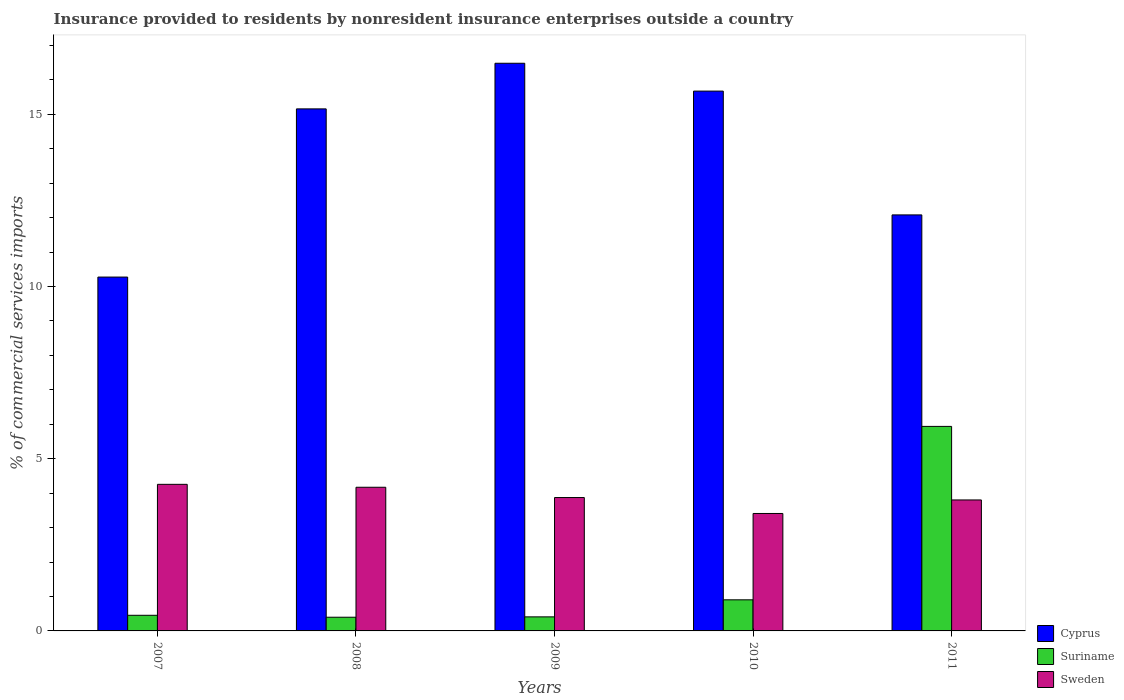How many groups of bars are there?
Provide a short and direct response. 5. Are the number of bars on each tick of the X-axis equal?
Give a very brief answer. Yes. In how many cases, is the number of bars for a given year not equal to the number of legend labels?
Make the answer very short. 0. What is the Insurance provided to residents in Suriname in 2010?
Your response must be concise. 0.9. Across all years, what is the maximum Insurance provided to residents in Sweden?
Provide a succinct answer. 4.26. Across all years, what is the minimum Insurance provided to residents in Sweden?
Your response must be concise. 3.41. In which year was the Insurance provided to residents in Cyprus maximum?
Your response must be concise. 2009. In which year was the Insurance provided to residents in Suriname minimum?
Ensure brevity in your answer.  2008. What is the total Insurance provided to residents in Sweden in the graph?
Your response must be concise. 19.52. What is the difference between the Insurance provided to residents in Sweden in 2010 and that in 2011?
Ensure brevity in your answer.  -0.39. What is the difference between the Insurance provided to residents in Sweden in 2007 and the Insurance provided to residents in Suriname in 2009?
Keep it short and to the point. 3.85. What is the average Insurance provided to residents in Cyprus per year?
Your answer should be very brief. 13.93. In the year 2011, what is the difference between the Insurance provided to residents in Cyprus and Insurance provided to residents in Sweden?
Provide a short and direct response. 8.28. In how many years, is the Insurance provided to residents in Cyprus greater than 16 %?
Provide a short and direct response. 1. What is the ratio of the Insurance provided to residents in Sweden in 2007 to that in 2008?
Provide a short and direct response. 1.02. Is the Insurance provided to residents in Cyprus in 2009 less than that in 2010?
Keep it short and to the point. No. What is the difference between the highest and the second highest Insurance provided to residents in Cyprus?
Offer a very short reply. 0.81. What is the difference between the highest and the lowest Insurance provided to residents in Cyprus?
Offer a terse response. 6.21. In how many years, is the Insurance provided to residents in Cyprus greater than the average Insurance provided to residents in Cyprus taken over all years?
Your answer should be very brief. 3. Is the sum of the Insurance provided to residents in Sweden in 2010 and 2011 greater than the maximum Insurance provided to residents in Cyprus across all years?
Provide a succinct answer. No. What does the 1st bar from the left in 2008 represents?
Your answer should be compact. Cyprus. What does the 3rd bar from the right in 2010 represents?
Ensure brevity in your answer.  Cyprus. Are all the bars in the graph horizontal?
Ensure brevity in your answer.  No. How many years are there in the graph?
Your response must be concise. 5. What is the difference between two consecutive major ticks on the Y-axis?
Offer a terse response. 5. Are the values on the major ticks of Y-axis written in scientific E-notation?
Keep it short and to the point. No. Does the graph contain any zero values?
Provide a succinct answer. No. Where does the legend appear in the graph?
Provide a succinct answer. Bottom right. How are the legend labels stacked?
Make the answer very short. Vertical. What is the title of the graph?
Ensure brevity in your answer.  Insurance provided to residents by nonresident insurance enterprises outside a country. Does "Croatia" appear as one of the legend labels in the graph?
Give a very brief answer. No. What is the label or title of the X-axis?
Your answer should be compact. Years. What is the label or title of the Y-axis?
Provide a succinct answer. % of commercial services imports. What is the % of commercial services imports of Cyprus in 2007?
Your answer should be compact. 10.28. What is the % of commercial services imports of Suriname in 2007?
Give a very brief answer. 0.45. What is the % of commercial services imports of Sweden in 2007?
Give a very brief answer. 4.26. What is the % of commercial services imports in Cyprus in 2008?
Make the answer very short. 15.16. What is the % of commercial services imports in Suriname in 2008?
Keep it short and to the point. 0.4. What is the % of commercial services imports in Sweden in 2008?
Your response must be concise. 4.17. What is the % of commercial services imports of Cyprus in 2009?
Ensure brevity in your answer.  16.48. What is the % of commercial services imports of Suriname in 2009?
Offer a terse response. 0.41. What is the % of commercial services imports of Sweden in 2009?
Keep it short and to the point. 3.87. What is the % of commercial services imports in Cyprus in 2010?
Ensure brevity in your answer.  15.68. What is the % of commercial services imports of Suriname in 2010?
Provide a succinct answer. 0.9. What is the % of commercial services imports of Sweden in 2010?
Ensure brevity in your answer.  3.41. What is the % of commercial services imports of Cyprus in 2011?
Your answer should be compact. 12.08. What is the % of commercial services imports in Suriname in 2011?
Your answer should be compact. 5.94. What is the % of commercial services imports of Sweden in 2011?
Your response must be concise. 3.8. Across all years, what is the maximum % of commercial services imports of Cyprus?
Make the answer very short. 16.48. Across all years, what is the maximum % of commercial services imports of Suriname?
Provide a succinct answer. 5.94. Across all years, what is the maximum % of commercial services imports of Sweden?
Provide a succinct answer. 4.26. Across all years, what is the minimum % of commercial services imports of Cyprus?
Offer a very short reply. 10.28. Across all years, what is the minimum % of commercial services imports of Suriname?
Your response must be concise. 0.4. Across all years, what is the minimum % of commercial services imports of Sweden?
Your answer should be very brief. 3.41. What is the total % of commercial services imports of Cyprus in the graph?
Your answer should be compact. 69.67. What is the total % of commercial services imports of Suriname in the graph?
Offer a very short reply. 8.1. What is the total % of commercial services imports in Sweden in the graph?
Offer a very short reply. 19.52. What is the difference between the % of commercial services imports of Cyprus in 2007 and that in 2008?
Make the answer very short. -4.88. What is the difference between the % of commercial services imports of Suriname in 2007 and that in 2008?
Give a very brief answer. 0.06. What is the difference between the % of commercial services imports in Sweden in 2007 and that in 2008?
Make the answer very short. 0.08. What is the difference between the % of commercial services imports of Cyprus in 2007 and that in 2009?
Give a very brief answer. -6.21. What is the difference between the % of commercial services imports in Suriname in 2007 and that in 2009?
Ensure brevity in your answer.  0.05. What is the difference between the % of commercial services imports of Sweden in 2007 and that in 2009?
Offer a terse response. 0.38. What is the difference between the % of commercial services imports in Cyprus in 2007 and that in 2010?
Provide a short and direct response. -5.4. What is the difference between the % of commercial services imports in Suriname in 2007 and that in 2010?
Provide a succinct answer. -0.45. What is the difference between the % of commercial services imports in Sweden in 2007 and that in 2010?
Your answer should be compact. 0.85. What is the difference between the % of commercial services imports of Cyprus in 2007 and that in 2011?
Provide a short and direct response. -1.81. What is the difference between the % of commercial services imports in Suriname in 2007 and that in 2011?
Offer a terse response. -5.49. What is the difference between the % of commercial services imports of Sweden in 2007 and that in 2011?
Provide a succinct answer. 0.45. What is the difference between the % of commercial services imports in Cyprus in 2008 and that in 2009?
Offer a terse response. -1.32. What is the difference between the % of commercial services imports in Suriname in 2008 and that in 2009?
Your answer should be compact. -0.01. What is the difference between the % of commercial services imports of Sweden in 2008 and that in 2009?
Provide a short and direct response. 0.3. What is the difference between the % of commercial services imports in Cyprus in 2008 and that in 2010?
Give a very brief answer. -0.52. What is the difference between the % of commercial services imports of Suriname in 2008 and that in 2010?
Provide a succinct answer. -0.51. What is the difference between the % of commercial services imports of Sweden in 2008 and that in 2010?
Ensure brevity in your answer.  0.76. What is the difference between the % of commercial services imports in Cyprus in 2008 and that in 2011?
Make the answer very short. 3.08. What is the difference between the % of commercial services imports in Suriname in 2008 and that in 2011?
Your answer should be very brief. -5.54. What is the difference between the % of commercial services imports in Sweden in 2008 and that in 2011?
Ensure brevity in your answer.  0.37. What is the difference between the % of commercial services imports of Cyprus in 2009 and that in 2010?
Your answer should be very brief. 0.81. What is the difference between the % of commercial services imports of Suriname in 2009 and that in 2010?
Your response must be concise. -0.49. What is the difference between the % of commercial services imports of Sweden in 2009 and that in 2010?
Provide a short and direct response. 0.46. What is the difference between the % of commercial services imports in Cyprus in 2009 and that in 2011?
Give a very brief answer. 4.4. What is the difference between the % of commercial services imports in Suriname in 2009 and that in 2011?
Your answer should be very brief. -5.53. What is the difference between the % of commercial services imports of Sweden in 2009 and that in 2011?
Ensure brevity in your answer.  0.07. What is the difference between the % of commercial services imports of Cyprus in 2010 and that in 2011?
Your response must be concise. 3.6. What is the difference between the % of commercial services imports in Suriname in 2010 and that in 2011?
Offer a very short reply. -5.04. What is the difference between the % of commercial services imports of Sweden in 2010 and that in 2011?
Your answer should be compact. -0.39. What is the difference between the % of commercial services imports of Cyprus in 2007 and the % of commercial services imports of Suriname in 2008?
Provide a short and direct response. 9.88. What is the difference between the % of commercial services imports in Cyprus in 2007 and the % of commercial services imports in Sweden in 2008?
Ensure brevity in your answer.  6.1. What is the difference between the % of commercial services imports of Suriname in 2007 and the % of commercial services imports of Sweden in 2008?
Make the answer very short. -3.72. What is the difference between the % of commercial services imports in Cyprus in 2007 and the % of commercial services imports in Suriname in 2009?
Your answer should be very brief. 9.87. What is the difference between the % of commercial services imports of Cyprus in 2007 and the % of commercial services imports of Sweden in 2009?
Provide a short and direct response. 6.4. What is the difference between the % of commercial services imports of Suriname in 2007 and the % of commercial services imports of Sweden in 2009?
Give a very brief answer. -3.42. What is the difference between the % of commercial services imports in Cyprus in 2007 and the % of commercial services imports in Suriname in 2010?
Offer a terse response. 9.37. What is the difference between the % of commercial services imports of Cyprus in 2007 and the % of commercial services imports of Sweden in 2010?
Keep it short and to the point. 6.86. What is the difference between the % of commercial services imports in Suriname in 2007 and the % of commercial services imports in Sweden in 2010?
Give a very brief answer. -2.96. What is the difference between the % of commercial services imports in Cyprus in 2007 and the % of commercial services imports in Suriname in 2011?
Keep it short and to the point. 4.34. What is the difference between the % of commercial services imports of Cyprus in 2007 and the % of commercial services imports of Sweden in 2011?
Your response must be concise. 6.47. What is the difference between the % of commercial services imports in Suriname in 2007 and the % of commercial services imports in Sweden in 2011?
Your response must be concise. -3.35. What is the difference between the % of commercial services imports of Cyprus in 2008 and the % of commercial services imports of Suriname in 2009?
Offer a very short reply. 14.75. What is the difference between the % of commercial services imports in Cyprus in 2008 and the % of commercial services imports in Sweden in 2009?
Your response must be concise. 11.29. What is the difference between the % of commercial services imports in Suriname in 2008 and the % of commercial services imports in Sweden in 2009?
Ensure brevity in your answer.  -3.48. What is the difference between the % of commercial services imports in Cyprus in 2008 and the % of commercial services imports in Suriname in 2010?
Offer a terse response. 14.26. What is the difference between the % of commercial services imports of Cyprus in 2008 and the % of commercial services imports of Sweden in 2010?
Keep it short and to the point. 11.75. What is the difference between the % of commercial services imports of Suriname in 2008 and the % of commercial services imports of Sweden in 2010?
Your answer should be compact. -3.01. What is the difference between the % of commercial services imports of Cyprus in 2008 and the % of commercial services imports of Suriname in 2011?
Keep it short and to the point. 9.22. What is the difference between the % of commercial services imports in Cyprus in 2008 and the % of commercial services imports in Sweden in 2011?
Your answer should be compact. 11.36. What is the difference between the % of commercial services imports of Suriname in 2008 and the % of commercial services imports of Sweden in 2011?
Provide a succinct answer. -3.41. What is the difference between the % of commercial services imports in Cyprus in 2009 and the % of commercial services imports in Suriname in 2010?
Your answer should be very brief. 15.58. What is the difference between the % of commercial services imports of Cyprus in 2009 and the % of commercial services imports of Sweden in 2010?
Give a very brief answer. 13.07. What is the difference between the % of commercial services imports in Suriname in 2009 and the % of commercial services imports in Sweden in 2010?
Keep it short and to the point. -3. What is the difference between the % of commercial services imports of Cyprus in 2009 and the % of commercial services imports of Suriname in 2011?
Keep it short and to the point. 10.55. What is the difference between the % of commercial services imports in Cyprus in 2009 and the % of commercial services imports in Sweden in 2011?
Ensure brevity in your answer.  12.68. What is the difference between the % of commercial services imports in Suriname in 2009 and the % of commercial services imports in Sweden in 2011?
Provide a succinct answer. -3.4. What is the difference between the % of commercial services imports of Cyprus in 2010 and the % of commercial services imports of Suriname in 2011?
Ensure brevity in your answer.  9.74. What is the difference between the % of commercial services imports in Cyprus in 2010 and the % of commercial services imports in Sweden in 2011?
Ensure brevity in your answer.  11.87. What is the difference between the % of commercial services imports of Suriname in 2010 and the % of commercial services imports of Sweden in 2011?
Provide a succinct answer. -2.9. What is the average % of commercial services imports of Cyprus per year?
Offer a terse response. 13.93. What is the average % of commercial services imports of Suriname per year?
Provide a succinct answer. 1.62. What is the average % of commercial services imports of Sweden per year?
Provide a succinct answer. 3.9. In the year 2007, what is the difference between the % of commercial services imports of Cyprus and % of commercial services imports of Suriname?
Your answer should be compact. 9.82. In the year 2007, what is the difference between the % of commercial services imports of Cyprus and % of commercial services imports of Sweden?
Offer a very short reply. 6.02. In the year 2007, what is the difference between the % of commercial services imports in Suriname and % of commercial services imports in Sweden?
Give a very brief answer. -3.8. In the year 2008, what is the difference between the % of commercial services imports of Cyprus and % of commercial services imports of Suriname?
Offer a very short reply. 14.76. In the year 2008, what is the difference between the % of commercial services imports in Cyprus and % of commercial services imports in Sweden?
Keep it short and to the point. 10.99. In the year 2008, what is the difference between the % of commercial services imports of Suriname and % of commercial services imports of Sweden?
Offer a terse response. -3.77. In the year 2009, what is the difference between the % of commercial services imports of Cyprus and % of commercial services imports of Suriname?
Your answer should be very brief. 16.08. In the year 2009, what is the difference between the % of commercial services imports in Cyprus and % of commercial services imports in Sweden?
Offer a terse response. 12.61. In the year 2009, what is the difference between the % of commercial services imports in Suriname and % of commercial services imports in Sweden?
Offer a terse response. -3.47. In the year 2010, what is the difference between the % of commercial services imports in Cyprus and % of commercial services imports in Suriname?
Give a very brief answer. 14.77. In the year 2010, what is the difference between the % of commercial services imports of Cyprus and % of commercial services imports of Sweden?
Offer a terse response. 12.27. In the year 2010, what is the difference between the % of commercial services imports of Suriname and % of commercial services imports of Sweden?
Your response must be concise. -2.51. In the year 2011, what is the difference between the % of commercial services imports in Cyprus and % of commercial services imports in Suriname?
Offer a very short reply. 6.14. In the year 2011, what is the difference between the % of commercial services imports in Cyprus and % of commercial services imports in Sweden?
Give a very brief answer. 8.28. In the year 2011, what is the difference between the % of commercial services imports of Suriname and % of commercial services imports of Sweden?
Give a very brief answer. 2.14. What is the ratio of the % of commercial services imports in Cyprus in 2007 to that in 2008?
Provide a short and direct response. 0.68. What is the ratio of the % of commercial services imports in Suriname in 2007 to that in 2008?
Ensure brevity in your answer.  1.14. What is the ratio of the % of commercial services imports of Sweden in 2007 to that in 2008?
Your answer should be compact. 1.02. What is the ratio of the % of commercial services imports in Cyprus in 2007 to that in 2009?
Provide a succinct answer. 0.62. What is the ratio of the % of commercial services imports in Suriname in 2007 to that in 2009?
Keep it short and to the point. 1.11. What is the ratio of the % of commercial services imports in Sweden in 2007 to that in 2009?
Offer a terse response. 1.1. What is the ratio of the % of commercial services imports of Cyprus in 2007 to that in 2010?
Provide a short and direct response. 0.66. What is the ratio of the % of commercial services imports in Suriname in 2007 to that in 2010?
Your response must be concise. 0.5. What is the ratio of the % of commercial services imports of Sweden in 2007 to that in 2010?
Give a very brief answer. 1.25. What is the ratio of the % of commercial services imports in Cyprus in 2007 to that in 2011?
Ensure brevity in your answer.  0.85. What is the ratio of the % of commercial services imports of Suriname in 2007 to that in 2011?
Offer a very short reply. 0.08. What is the ratio of the % of commercial services imports of Sweden in 2007 to that in 2011?
Offer a terse response. 1.12. What is the ratio of the % of commercial services imports of Cyprus in 2008 to that in 2009?
Ensure brevity in your answer.  0.92. What is the ratio of the % of commercial services imports in Suriname in 2008 to that in 2009?
Offer a very short reply. 0.97. What is the ratio of the % of commercial services imports in Sweden in 2008 to that in 2009?
Keep it short and to the point. 1.08. What is the ratio of the % of commercial services imports of Suriname in 2008 to that in 2010?
Offer a very short reply. 0.44. What is the ratio of the % of commercial services imports of Sweden in 2008 to that in 2010?
Keep it short and to the point. 1.22. What is the ratio of the % of commercial services imports of Cyprus in 2008 to that in 2011?
Offer a terse response. 1.25. What is the ratio of the % of commercial services imports in Suriname in 2008 to that in 2011?
Offer a terse response. 0.07. What is the ratio of the % of commercial services imports in Sweden in 2008 to that in 2011?
Your answer should be very brief. 1.1. What is the ratio of the % of commercial services imports of Cyprus in 2009 to that in 2010?
Provide a short and direct response. 1.05. What is the ratio of the % of commercial services imports of Suriname in 2009 to that in 2010?
Make the answer very short. 0.45. What is the ratio of the % of commercial services imports of Sweden in 2009 to that in 2010?
Your response must be concise. 1.14. What is the ratio of the % of commercial services imports in Cyprus in 2009 to that in 2011?
Offer a very short reply. 1.36. What is the ratio of the % of commercial services imports in Suriname in 2009 to that in 2011?
Make the answer very short. 0.07. What is the ratio of the % of commercial services imports of Sweden in 2009 to that in 2011?
Offer a very short reply. 1.02. What is the ratio of the % of commercial services imports of Cyprus in 2010 to that in 2011?
Your response must be concise. 1.3. What is the ratio of the % of commercial services imports of Suriname in 2010 to that in 2011?
Your answer should be compact. 0.15. What is the ratio of the % of commercial services imports in Sweden in 2010 to that in 2011?
Make the answer very short. 0.9. What is the difference between the highest and the second highest % of commercial services imports of Cyprus?
Offer a very short reply. 0.81. What is the difference between the highest and the second highest % of commercial services imports in Suriname?
Your answer should be compact. 5.04. What is the difference between the highest and the second highest % of commercial services imports in Sweden?
Provide a succinct answer. 0.08. What is the difference between the highest and the lowest % of commercial services imports in Cyprus?
Your answer should be very brief. 6.21. What is the difference between the highest and the lowest % of commercial services imports in Suriname?
Offer a very short reply. 5.54. What is the difference between the highest and the lowest % of commercial services imports of Sweden?
Give a very brief answer. 0.85. 